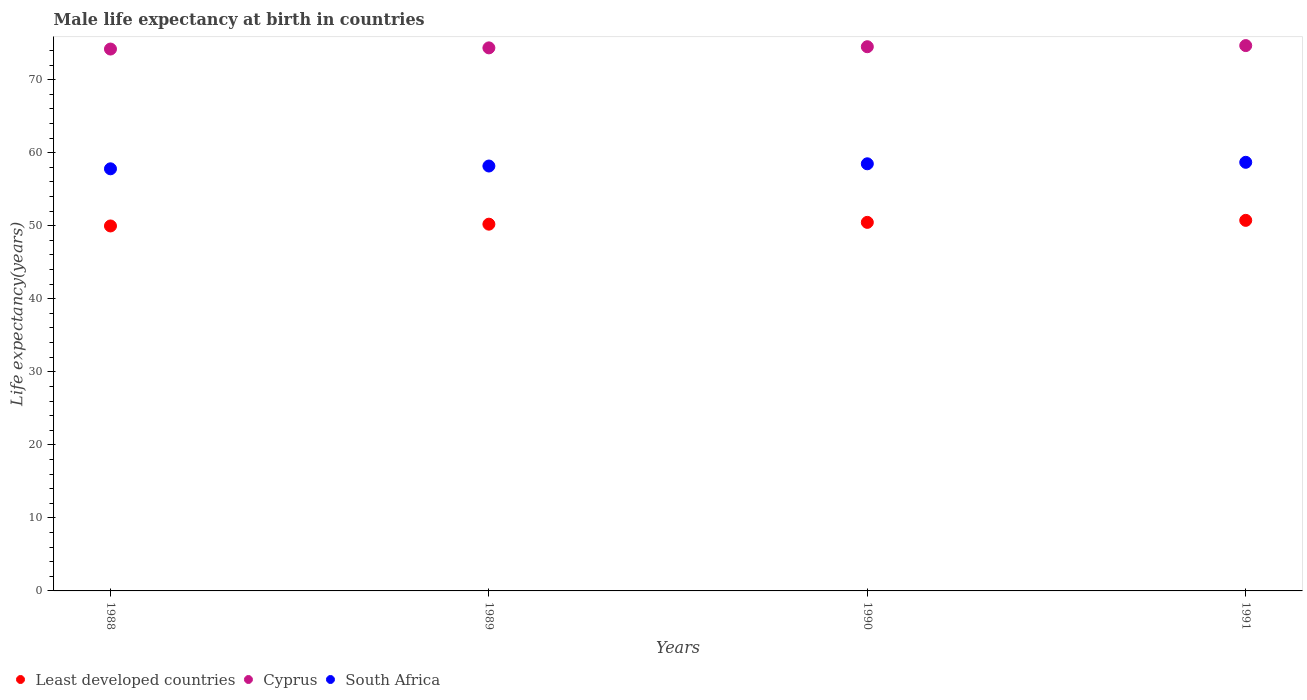Is the number of dotlines equal to the number of legend labels?
Keep it short and to the point. Yes. What is the male life expectancy at birth in Least developed countries in 1988?
Your response must be concise. 49.97. Across all years, what is the maximum male life expectancy at birth in Cyprus?
Offer a very short reply. 74.67. Across all years, what is the minimum male life expectancy at birth in South Africa?
Offer a very short reply. 57.8. In which year was the male life expectancy at birth in Cyprus maximum?
Your answer should be compact. 1991. In which year was the male life expectancy at birth in South Africa minimum?
Provide a short and direct response. 1988. What is the total male life expectancy at birth in Cyprus in the graph?
Give a very brief answer. 297.73. What is the difference between the male life expectancy at birth in Cyprus in 1989 and that in 1990?
Keep it short and to the point. -0.16. What is the difference between the male life expectancy at birth in Least developed countries in 1989 and the male life expectancy at birth in Cyprus in 1990?
Keep it short and to the point. -24.3. What is the average male life expectancy at birth in South Africa per year?
Your response must be concise. 58.29. In the year 1988, what is the difference between the male life expectancy at birth in Least developed countries and male life expectancy at birth in Cyprus?
Your response must be concise. -24.22. What is the ratio of the male life expectancy at birth in Cyprus in 1989 to that in 1990?
Your response must be concise. 1. What is the difference between the highest and the second highest male life expectancy at birth in Cyprus?
Offer a terse response. 0.16. What is the difference between the highest and the lowest male life expectancy at birth in Least developed countries?
Make the answer very short. 0.77. Is the sum of the male life expectancy at birth in Least developed countries in 1989 and 1990 greater than the maximum male life expectancy at birth in South Africa across all years?
Your answer should be compact. Yes. Is it the case that in every year, the sum of the male life expectancy at birth in South Africa and male life expectancy at birth in Cyprus  is greater than the male life expectancy at birth in Least developed countries?
Provide a short and direct response. Yes. How many years are there in the graph?
Offer a terse response. 4. What is the difference between two consecutive major ticks on the Y-axis?
Give a very brief answer. 10. Are the values on the major ticks of Y-axis written in scientific E-notation?
Your response must be concise. No. Does the graph contain grids?
Keep it short and to the point. No. Where does the legend appear in the graph?
Your response must be concise. Bottom left. How many legend labels are there?
Provide a succinct answer. 3. How are the legend labels stacked?
Ensure brevity in your answer.  Horizontal. What is the title of the graph?
Your response must be concise. Male life expectancy at birth in countries. What is the label or title of the X-axis?
Your answer should be very brief. Years. What is the label or title of the Y-axis?
Your answer should be compact. Life expectancy(years). What is the Life expectancy(years) in Least developed countries in 1988?
Keep it short and to the point. 49.97. What is the Life expectancy(years) of Cyprus in 1988?
Make the answer very short. 74.19. What is the Life expectancy(years) in South Africa in 1988?
Ensure brevity in your answer.  57.8. What is the Life expectancy(years) of Least developed countries in 1989?
Your response must be concise. 50.22. What is the Life expectancy(years) of Cyprus in 1989?
Your answer should be very brief. 74.36. What is the Life expectancy(years) in South Africa in 1989?
Provide a succinct answer. 58.18. What is the Life expectancy(years) in Least developed countries in 1990?
Keep it short and to the point. 50.46. What is the Life expectancy(years) in Cyprus in 1990?
Your answer should be very brief. 74.51. What is the Life expectancy(years) of South Africa in 1990?
Offer a terse response. 58.48. What is the Life expectancy(years) in Least developed countries in 1991?
Provide a short and direct response. 50.74. What is the Life expectancy(years) in Cyprus in 1991?
Your response must be concise. 74.67. What is the Life expectancy(years) in South Africa in 1991?
Your answer should be compact. 58.69. Across all years, what is the maximum Life expectancy(years) of Least developed countries?
Your answer should be compact. 50.74. Across all years, what is the maximum Life expectancy(years) in Cyprus?
Your answer should be compact. 74.67. Across all years, what is the maximum Life expectancy(years) of South Africa?
Your answer should be very brief. 58.69. Across all years, what is the minimum Life expectancy(years) in Least developed countries?
Provide a short and direct response. 49.97. Across all years, what is the minimum Life expectancy(years) of Cyprus?
Offer a very short reply. 74.19. Across all years, what is the minimum Life expectancy(years) in South Africa?
Your response must be concise. 57.8. What is the total Life expectancy(years) in Least developed countries in the graph?
Your response must be concise. 201.39. What is the total Life expectancy(years) of Cyprus in the graph?
Make the answer very short. 297.73. What is the total Life expectancy(years) of South Africa in the graph?
Your answer should be compact. 233.14. What is the difference between the Life expectancy(years) in Least developed countries in 1988 and that in 1989?
Ensure brevity in your answer.  -0.24. What is the difference between the Life expectancy(years) in Cyprus in 1988 and that in 1989?
Your response must be concise. -0.16. What is the difference between the Life expectancy(years) of South Africa in 1988 and that in 1989?
Ensure brevity in your answer.  -0.38. What is the difference between the Life expectancy(years) of Least developed countries in 1988 and that in 1990?
Your answer should be compact. -0.49. What is the difference between the Life expectancy(years) in Cyprus in 1988 and that in 1990?
Your answer should be very brief. -0.32. What is the difference between the Life expectancy(years) of South Africa in 1988 and that in 1990?
Your response must be concise. -0.69. What is the difference between the Life expectancy(years) in Least developed countries in 1988 and that in 1991?
Offer a terse response. -0.77. What is the difference between the Life expectancy(years) of Cyprus in 1988 and that in 1991?
Give a very brief answer. -0.47. What is the difference between the Life expectancy(years) in South Africa in 1988 and that in 1991?
Provide a succinct answer. -0.89. What is the difference between the Life expectancy(years) of Least developed countries in 1989 and that in 1990?
Offer a very short reply. -0.25. What is the difference between the Life expectancy(years) in Cyprus in 1989 and that in 1990?
Provide a succinct answer. -0.16. What is the difference between the Life expectancy(years) of South Africa in 1989 and that in 1990?
Give a very brief answer. -0.3. What is the difference between the Life expectancy(years) of Least developed countries in 1989 and that in 1991?
Offer a terse response. -0.52. What is the difference between the Life expectancy(years) of Cyprus in 1989 and that in 1991?
Your answer should be compact. -0.31. What is the difference between the Life expectancy(years) of South Africa in 1989 and that in 1991?
Your answer should be very brief. -0.51. What is the difference between the Life expectancy(years) of Least developed countries in 1990 and that in 1991?
Offer a terse response. -0.28. What is the difference between the Life expectancy(years) of Cyprus in 1990 and that in 1991?
Keep it short and to the point. -0.15. What is the difference between the Life expectancy(years) of South Africa in 1990 and that in 1991?
Your response must be concise. -0.2. What is the difference between the Life expectancy(years) of Least developed countries in 1988 and the Life expectancy(years) of Cyprus in 1989?
Offer a very short reply. -24.38. What is the difference between the Life expectancy(years) of Least developed countries in 1988 and the Life expectancy(years) of South Africa in 1989?
Your response must be concise. -8.21. What is the difference between the Life expectancy(years) of Cyprus in 1988 and the Life expectancy(years) of South Africa in 1989?
Provide a succinct answer. 16.02. What is the difference between the Life expectancy(years) in Least developed countries in 1988 and the Life expectancy(years) in Cyprus in 1990?
Your answer should be very brief. -24.54. What is the difference between the Life expectancy(years) in Least developed countries in 1988 and the Life expectancy(years) in South Africa in 1990?
Provide a short and direct response. -8.51. What is the difference between the Life expectancy(years) of Cyprus in 1988 and the Life expectancy(years) of South Africa in 1990?
Offer a very short reply. 15.71. What is the difference between the Life expectancy(years) of Least developed countries in 1988 and the Life expectancy(years) of Cyprus in 1991?
Give a very brief answer. -24.7. What is the difference between the Life expectancy(years) of Least developed countries in 1988 and the Life expectancy(years) of South Africa in 1991?
Give a very brief answer. -8.72. What is the difference between the Life expectancy(years) of Cyprus in 1988 and the Life expectancy(years) of South Africa in 1991?
Make the answer very short. 15.51. What is the difference between the Life expectancy(years) in Least developed countries in 1989 and the Life expectancy(years) in Cyprus in 1990?
Keep it short and to the point. -24.3. What is the difference between the Life expectancy(years) of Least developed countries in 1989 and the Life expectancy(years) of South Africa in 1990?
Offer a very short reply. -8.27. What is the difference between the Life expectancy(years) in Cyprus in 1989 and the Life expectancy(years) in South Africa in 1990?
Ensure brevity in your answer.  15.87. What is the difference between the Life expectancy(years) of Least developed countries in 1989 and the Life expectancy(years) of Cyprus in 1991?
Give a very brief answer. -24.45. What is the difference between the Life expectancy(years) in Least developed countries in 1989 and the Life expectancy(years) in South Africa in 1991?
Give a very brief answer. -8.47. What is the difference between the Life expectancy(years) in Cyprus in 1989 and the Life expectancy(years) in South Africa in 1991?
Your answer should be very brief. 15.67. What is the difference between the Life expectancy(years) of Least developed countries in 1990 and the Life expectancy(years) of Cyprus in 1991?
Your answer should be compact. -24.2. What is the difference between the Life expectancy(years) in Least developed countries in 1990 and the Life expectancy(years) in South Africa in 1991?
Your response must be concise. -8.22. What is the difference between the Life expectancy(years) in Cyprus in 1990 and the Life expectancy(years) in South Africa in 1991?
Provide a succinct answer. 15.82. What is the average Life expectancy(years) in Least developed countries per year?
Your answer should be very brief. 50.35. What is the average Life expectancy(years) in Cyprus per year?
Offer a very short reply. 74.43. What is the average Life expectancy(years) of South Africa per year?
Provide a succinct answer. 58.29. In the year 1988, what is the difference between the Life expectancy(years) of Least developed countries and Life expectancy(years) of Cyprus?
Provide a short and direct response. -24.22. In the year 1988, what is the difference between the Life expectancy(years) in Least developed countries and Life expectancy(years) in South Africa?
Provide a succinct answer. -7.82. In the year 1988, what is the difference between the Life expectancy(years) in Cyprus and Life expectancy(years) in South Africa?
Give a very brief answer. 16.4. In the year 1989, what is the difference between the Life expectancy(years) in Least developed countries and Life expectancy(years) in Cyprus?
Provide a succinct answer. -24.14. In the year 1989, what is the difference between the Life expectancy(years) of Least developed countries and Life expectancy(years) of South Africa?
Provide a short and direct response. -7.96. In the year 1989, what is the difference between the Life expectancy(years) in Cyprus and Life expectancy(years) in South Africa?
Your answer should be very brief. 16.18. In the year 1990, what is the difference between the Life expectancy(years) in Least developed countries and Life expectancy(years) in Cyprus?
Provide a succinct answer. -24.05. In the year 1990, what is the difference between the Life expectancy(years) in Least developed countries and Life expectancy(years) in South Africa?
Your response must be concise. -8.02. In the year 1990, what is the difference between the Life expectancy(years) in Cyprus and Life expectancy(years) in South Africa?
Make the answer very short. 16.03. In the year 1991, what is the difference between the Life expectancy(years) in Least developed countries and Life expectancy(years) in Cyprus?
Offer a very short reply. -23.93. In the year 1991, what is the difference between the Life expectancy(years) in Least developed countries and Life expectancy(years) in South Africa?
Make the answer very short. -7.95. In the year 1991, what is the difference between the Life expectancy(years) in Cyprus and Life expectancy(years) in South Africa?
Ensure brevity in your answer.  15.98. What is the ratio of the Life expectancy(years) of Least developed countries in 1988 to that in 1989?
Provide a succinct answer. 1. What is the ratio of the Life expectancy(years) in Least developed countries in 1988 to that in 1990?
Offer a very short reply. 0.99. What is the ratio of the Life expectancy(years) in South Africa in 1988 to that in 1990?
Give a very brief answer. 0.99. What is the ratio of the Life expectancy(years) of Least developed countries in 1988 to that in 1991?
Your answer should be compact. 0.98. What is the ratio of the Life expectancy(years) in South Africa in 1988 to that in 1991?
Your response must be concise. 0.98. What is the ratio of the Life expectancy(years) in Least developed countries in 1989 to that in 1990?
Offer a very short reply. 1. What is the ratio of the Life expectancy(years) of Cyprus in 1989 to that in 1990?
Offer a terse response. 1. What is the ratio of the Life expectancy(years) of South Africa in 1989 to that in 1990?
Make the answer very short. 0.99. What is the ratio of the Life expectancy(years) of Least developed countries in 1989 to that in 1991?
Offer a terse response. 0.99. What is the ratio of the Life expectancy(years) in Cyprus in 1989 to that in 1991?
Ensure brevity in your answer.  1. What is the ratio of the Life expectancy(years) of Least developed countries in 1990 to that in 1991?
Offer a terse response. 0.99. What is the ratio of the Life expectancy(years) in South Africa in 1990 to that in 1991?
Offer a terse response. 1. What is the difference between the highest and the second highest Life expectancy(years) of Least developed countries?
Offer a very short reply. 0.28. What is the difference between the highest and the second highest Life expectancy(years) of Cyprus?
Keep it short and to the point. 0.15. What is the difference between the highest and the second highest Life expectancy(years) in South Africa?
Offer a terse response. 0.2. What is the difference between the highest and the lowest Life expectancy(years) of Least developed countries?
Make the answer very short. 0.77. What is the difference between the highest and the lowest Life expectancy(years) of Cyprus?
Offer a terse response. 0.47. What is the difference between the highest and the lowest Life expectancy(years) in South Africa?
Your answer should be compact. 0.89. 